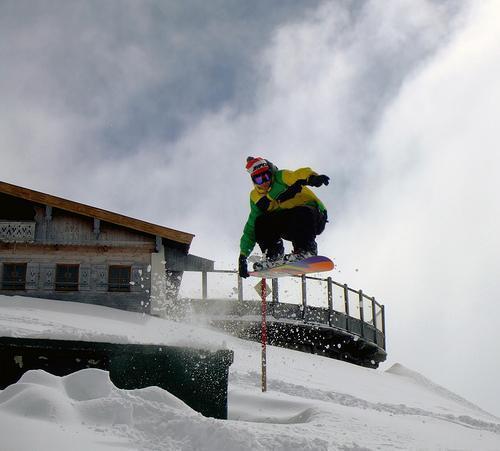How many people are in the photo?
Give a very brief answer. 1. 